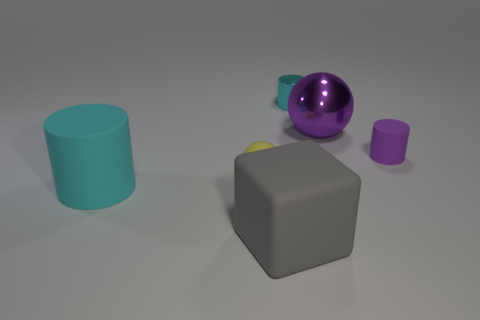The tiny thing that is both to the right of the gray rubber cube and in front of the large purple thing is made of what material?
Provide a succinct answer. Rubber. The purple rubber thing is what size?
Your response must be concise. Small. There is a big sphere; does it have the same color as the rubber cylinder to the right of the cyan metallic thing?
Give a very brief answer. Yes. What number of other objects are the same color as the matte ball?
Offer a very short reply. 0. Does the sphere that is right of the small cyan cylinder have the same size as the cyan thing right of the rubber block?
Provide a succinct answer. No. What is the color of the sphere on the left side of the metal sphere?
Your answer should be very brief. Yellow. Is the number of cyan matte things that are behind the big purple thing less than the number of shiny cylinders?
Give a very brief answer. Yes. Is the big cyan object made of the same material as the large purple object?
Offer a terse response. No. What is the size of the metallic object that is the same shape as the purple rubber thing?
Your response must be concise. Small. How many objects are tiny matte cylinders in front of the tiny cyan metal thing or small rubber objects behind the tiny ball?
Your answer should be very brief. 1. 